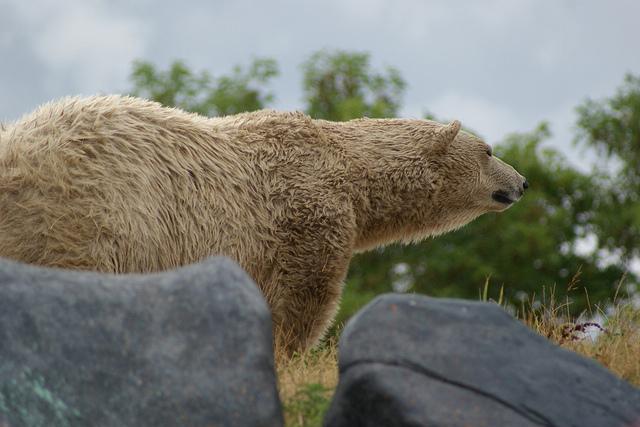About how tall is the bear?
Quick response, please. 7 feet. How many trees are there?
Answer briefly. 4. What color is the bear's fur?
Answer briefly. Tan. 